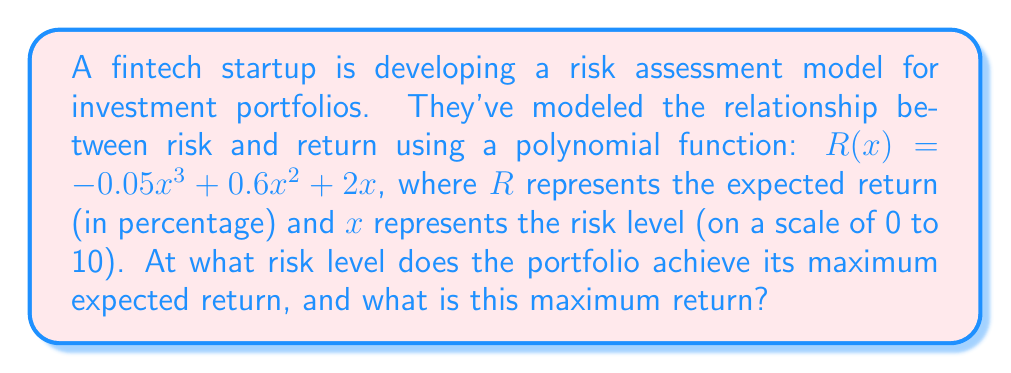Teach me how to tackle this problem. To find the maximum expected return and the corresponding risk level, we need to follow these steps:

1) Find the derivative of the function $R(x)$:
   $$R'(x) = -0.15x^2 + 1.2x + 2$$

2) Set the derivative equal to zero to find critical points:
   $$-0.15x^2 + 1.2x + 2 = 0$$

3) Solve this quadratic equation:
   $$a = -0.15, b = 1.2, c = 2$$
   $$x = \frac{-b \pm \sqrt{b^2 - 4ac}}{2a}$$
   $$x = \frac{-1.2 \pm \sqrt{1.44 - 4(-0.15)(2)}}{2(-0.15)}$$
   $$x = \frac{-1.2 \pm \sqrt{2.64}}{-0.3}$$
   $$x = \frac{-1.2 \pm 1.625}{-0.3}$$

   This gives us two solutions:
   $$x_1 = \frac{-1.2 + 1.625}{-0.3} \approx 1.42$$
   $$x_2 = \frac{-1.2 - 1.625}{-0.3} \approx 9.42$$

4) The second derivative is:
   $$R''(x) = -0.3x + 1.2$$
   
   At $x = 1.42$, $R''(1.42) > 0$, indicating a local minimum.
   At $x = 9.42$, $R''(9.42) < 0$, indicating a local maximum.

5) Therefore, the maximum return occurs at a risk level of approximately 9.42.

6) Calculate the maximum return by plugging this value back into the original function:
   $$R(9.42) = -0.05(9.42)^3 + 0.6(9.42)^2 + 2(9.42) \approx 41.78$$

Thus, the maximum expected return is approximately 41.78% at a risk level of 9.42.
Answer: Risk level: 9.42, Maximum return: 41.78% 